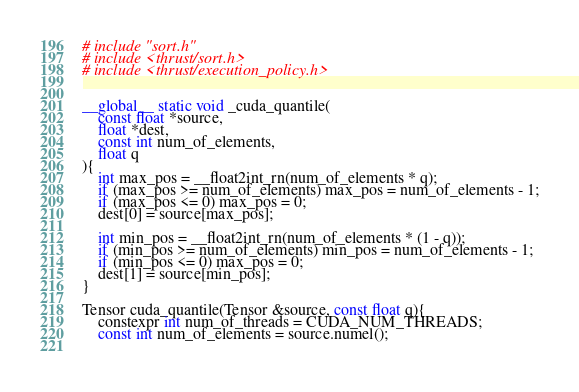Convert code to text. <code><loc_0><loc_0><loc_500><loc_500><_Cuda_># include "sort.h"
# include <thrust/sort.h>
# include <thrust/execution_policy.h>


__global__ static void _cuda_quantile(
    const float *source,
    float *dest,
    const int num_of_elements,
    float q
){
    int max_pos = __float2int_rn(num_of_elements * q);
    if (max_pos >= num_of_elements) max_pos = num_of_elements - 1;
    if (max_pos <= 0) max_pos = 0;
    dest[0] = source[max_pos];

    int min_pos = __float2int_rn(num_of_elements * (1 - q));
    if (min_pos >= num_of_elements) min_pos = num_of_elements - 1;
    if (min_pos <= 0) max_pos = 0;
    dest[1] = source[min_pos];
}

Tensor cuda_quantile(Tensor &source, const float q){
    constexpr int num_of_threads = CUDA_NUM_THREADS;
    const int num_of_elements = source.numel();
    </code> 